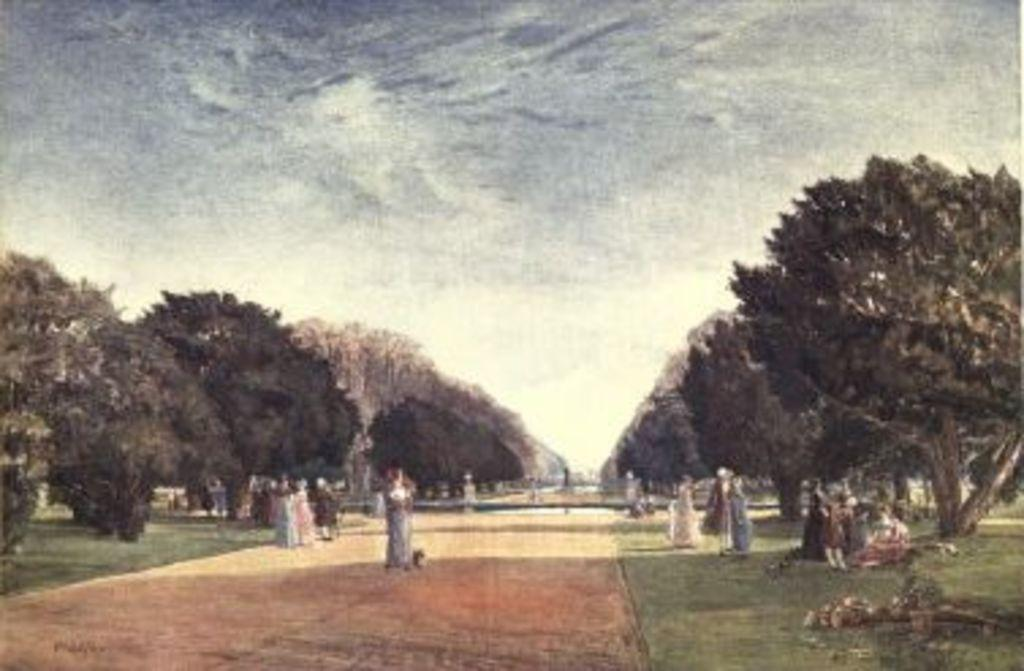What type of natural elements are present in the painting? The painting contains trees and a grassy land. Are there any human figures in the painting? Yes, there are people in the painting. What other features can be seen in the painting? There is a road and the sky is visible in the painting. What type of books are being used as a table for the feast in the painting? There are no books or feast present in the painting; it depicts a grassy land with trees, people, a road, and the sky. Can you describe the cub that is playing with the people in the painting? There is no cub present in the painting; it only features trees, people, a road, and the sky. 